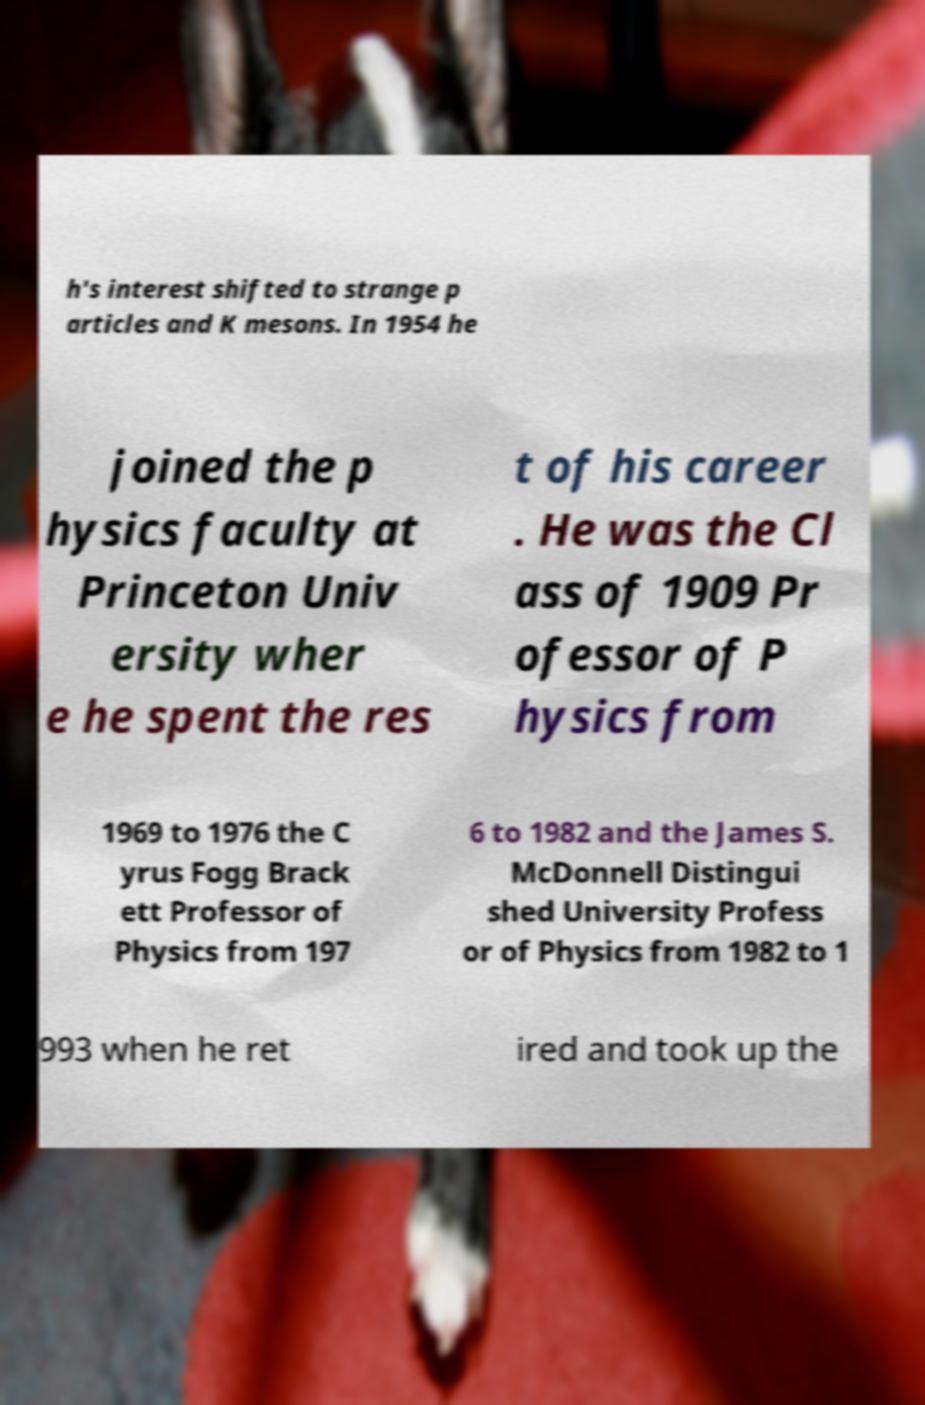For documentation purposes, I need the text within this image transcribed. Could you provide that? h's interest shifted to strange p articles and K mesons. In 1954 he joined the p hysics faculty at Princeton Univ ersity wher e he spent the res t of his career . He was the Cl ass of 1909 Pr ofessor of P hysics from 1969 to 1976 the C yrus Fogg Brack ett Professor of Physics from 197 6 to 1982 and the James S. McDonnell Distingui shed University Profess or of Physics from 1982 to 1 993 when he ret ired and took up the 